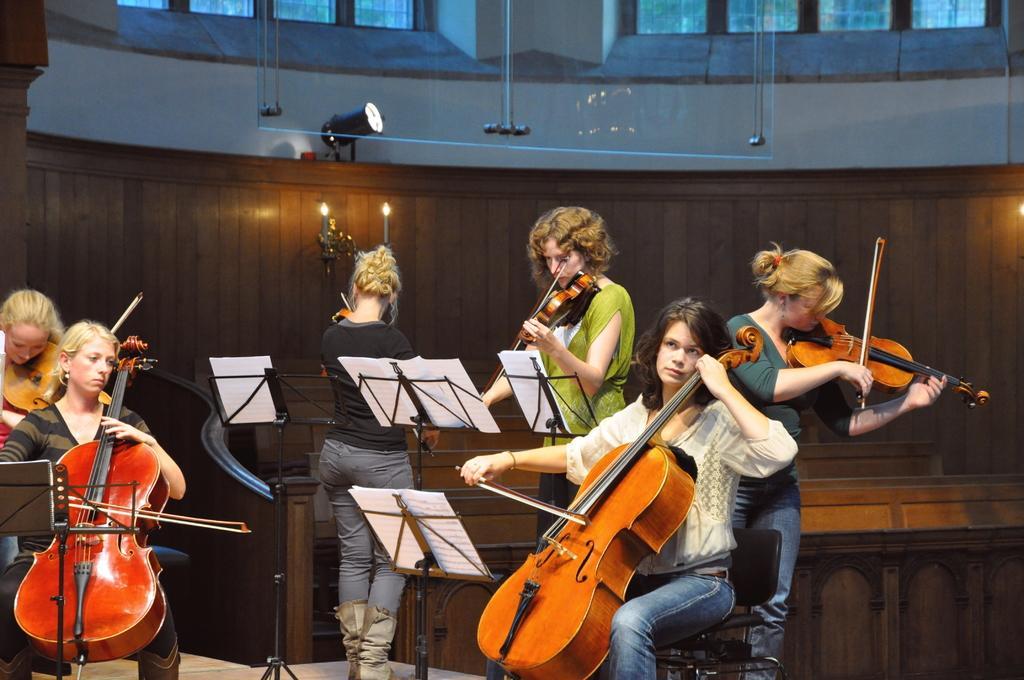Can you describe this image briefly? In this image, there are a few people playing musical instruments. We can see some stands with posters. We can also see the ground. We can see some wooden objects. We can see the wall with an object and a few windows. We can also see an object at the top. 